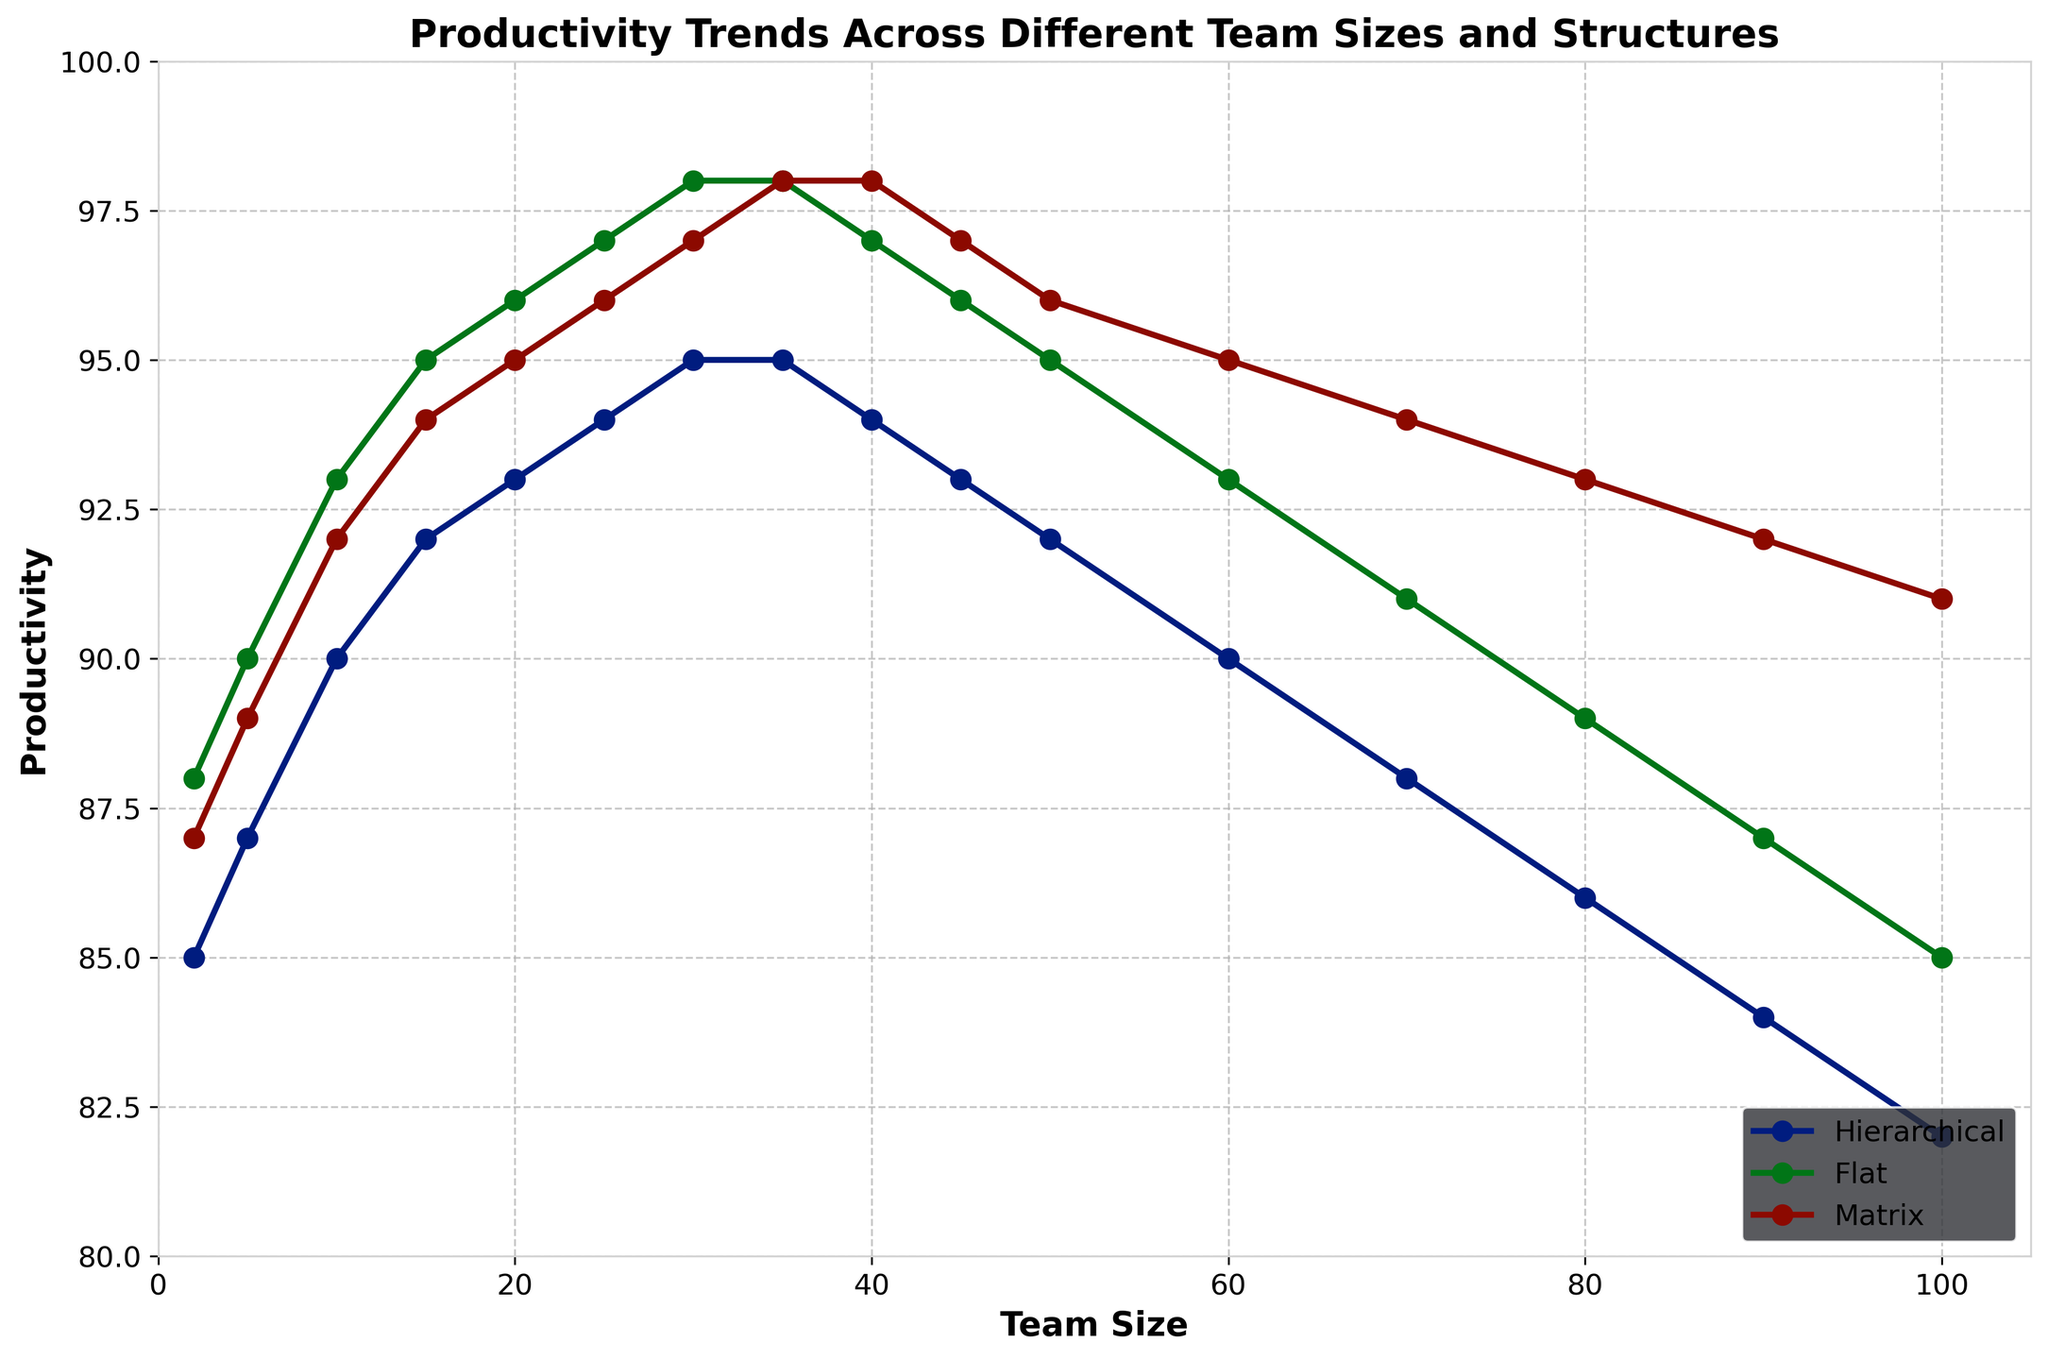What's the highest productivity value across all team structures? By observing the y-axis, the highest productivity value across all team structures is 98. This value is reached by both Flat and Matrix structures at varying team sizes.
Answer: 98 Which team structure maintains consistently high productivity as team size increases? Examining the trend lines, the Flat and Matrix structures maintain consistently high productivity, peaking at 98 as team size increases.
Answer: Flat and Matrix How does productivity change for the Hierarchical structure between a team size of 2 and a team size of 100? Looking at the plot, the productivity for the Hierarchical structure starts at 85 for a team size of 2 and decreases to 82 for a team size of 100.
Answer: Decreases from 85 to 82 At what team size do all three structures have the same productivity? By scanning the plot, we see that all three structures converge at a productivity value of 98 for a team size of 35.
Answer: 35 What is the difference in productivity between the Flat and Hierarchical structures at team size 50? From the plot, at team size 50, the Flat structure has a productivity of 95 and the Hierarchical structure has a productivity of 92. The difference is 95 - 92 = 3.
Answer: 3 When does productivity for the Matrix structure start to decline? Observing the Matrix trend line, productivity begins to decline after reaching its peak of 98 at a team size of 35, gradually decreasing thereafter.
Answer: After team size 35 Compare the productivity at a team size of 80 for both Flat and Matrix structures. Who performs better? At team size 80, the plot shows that the Flat structure has a productivity of 89, while the Matrix structure has 93. The Matrix structure performs better.
Answer: Matrix What's the average productivity of the Flat structure across all team sizes shown? Adding productivity values for the Flat structure: 88 + 90 + 93 + 95 + 96 + 97 + 98 + 98 + 97 + 96 + 95 + 93 + 91 + 89 + 87 + 85 = 1389. Dividing by 16 team sizes gives us 1389 / 16 = ~86.81.
Answer: ~86.81 Determine the productivity range (difference between the highest and lowest productivity values) for the Hierarchical structure. The highest productivity for the Hierarchical structure is 95 and the lowest is 82. The range is 95 - 82 = 13.
Answer: 13 